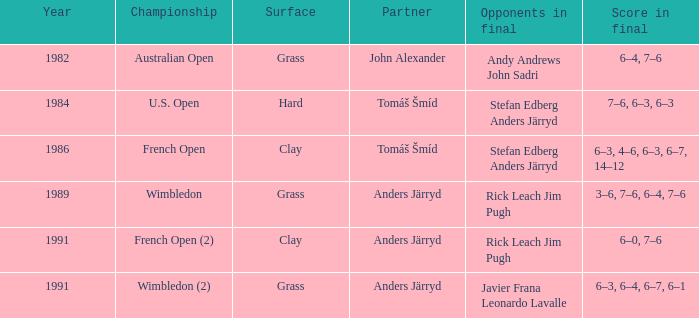What did the final tally amount to in 1986? 6–3, 4–6, 6–3, 6–7, 14–12. 